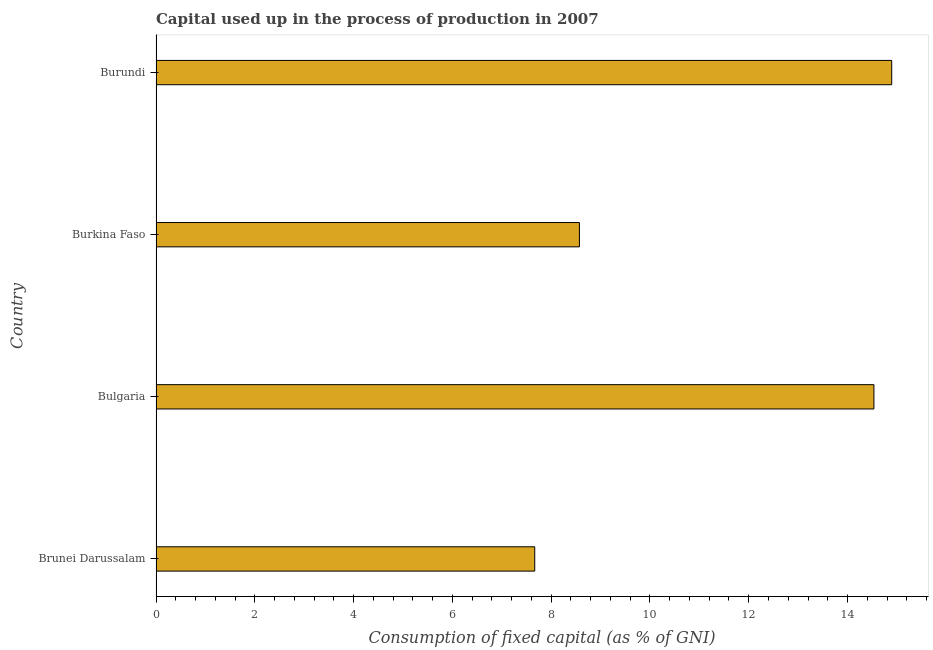Does the graph contain any zero values?
Your answer should be very brief. No. Does the graph contain grids?
Ensure brevity in your answer.  No. What is the title of the graph?
Give a very brief answer. Capital used up in the process of production in 2007. What is the label or title of the X-axis?
Keep it short and to the point. Consumption of fixed capital (as % of GNI). What is the label or title of the Y-axis?
Your answer should be very brief. Country. What is the consumption of fixed capital in Burundi?
Offer a terse response. 14.89. Across all countries, what is the maximum consumption of fixed capital?
Offer a terse response. 14.89. Across all countries, what is the minimum consumption of fixed capital?
Your answer should be compact. 7.67. In which country was the consumption of fixed capital maximum?
Offer a terse response. Burundi. In which country was the consumption of fixed capital minimum?
Your response must be concise. Brunei Darussalam. What is the sum of the consumption of fixed capital?
Your answer should be compact. 45.67. What is the difference between the consumption of fixed capital in Brunei Darussalam and Burkina Faso?
Provide a succinct answer. -0.9. What is the average consumption of fixed capital per country?
Provide a short and direct response. 11.42. What is the median consumption of fixed capital?
Your answer should be compact. 11.55. In how many countries, is the consumption of fixed capital greater than 0.4 %?
Your answer should be very brief. 4. What is the ratio of the consumption of fixed capital in Burkina Faso to that in Burundi?
Give a very brief answer. 0.57. Is the consumption of fixed capital in Burkina Faso less than that in Burundi?
Your answer should be compact. Yes. Is the difference between the consumption of fixed capital in Brunei Darussalam and Burkina Faso greater than the difference between any two countries?
Make the answer very short. No. What is the difference between the highest and the second highest consumption of fixed capital?
Your answer should be very brief. 0.36. What is the difference between the highest and the lowest consumption of fixed capital?
Make the answer very short. 7.23. How many bars are there?
Offer a very short reply. 4. How many countries are there in the graph?
Offer a terse response. 4. What is the difference between two consecutive major ticks on the X-axis?
Provide a short and direct response. 2. What is the Consumption of fixed capital (as % of GNI) of Brunei Darussalam?
Offer a very short reply. 7.67. What is the Consumption of fixed capital (as % of GNI) in Bulgaria?
Provide a short and direct response. 14.53. What is the Consumption of fixed capital (as % of GNI) in Burkina Faso?
Ensure brevity in your answer.  8.57. What is the Consumption of fixed capital (as % of GNI) in Burundi?
Give a very brief answer. 14.89. What is the difference between the Consumption of fixed capital (as % of GNI) in Brunei Darussalam and Bulgaria?
Offer a very short reply. -6.87. What is the difference between the Consumption of fixed capital (as % of GNI) in Brunei Darussalam and Burkina Faso?
Your response must be concise. -0.9. What is the difference between the Consumption of fixed capital (as % of GNI) in Brunei Darussalam and Burundi?
Your answer should be very brief. -7.23. What is the difference between the Consumption of fixed capital (as % of GNI) in Bulgaria and Burkina Faso?
Your response must be concise. 5.96. What is the difference between the Consumption of fixed capital (as % of GNI) in Bulgaria and Burundi?
Your answer should be compact. -0.36. What is the difference between the Consumption of fixed capital (as % of GNI) in Burkina Faso and Burundi?
Your answer should be very brief. -6.32. What is the ratio of the Consumption of fixed capital (as % of GNI) in Brunei Darussalam to that in Bulgaria?
Offer a terse response. 0.53. What is the ratio of the Consumption of fixed capital (as % of GNI) in Brunei Darussalam to that in Burkina Faso?
Your answer should be compact. 0.9. What is the ratio of the Consumption of fixed capital (as % of GNI) in Brunei Darussalam to that in Burundi?
Give a very brief answer. 0.52. What is the ratio of the Consumption of fixed capital (as % of GNI) in Bulgaria to that in Burkina Faso?
Provide a short and direct response. 1.7. What is the ratio of the Consumption of fixed capital (as % of GNI) in Bulgaria to that in Burundi?
Ensure brevity in your answer.  0.98. What is the ratio of the Consumption of fixed capital (as % of GNI) in Burkina Faso to that in Burundi?
Give a very brief answer. 0.57. 